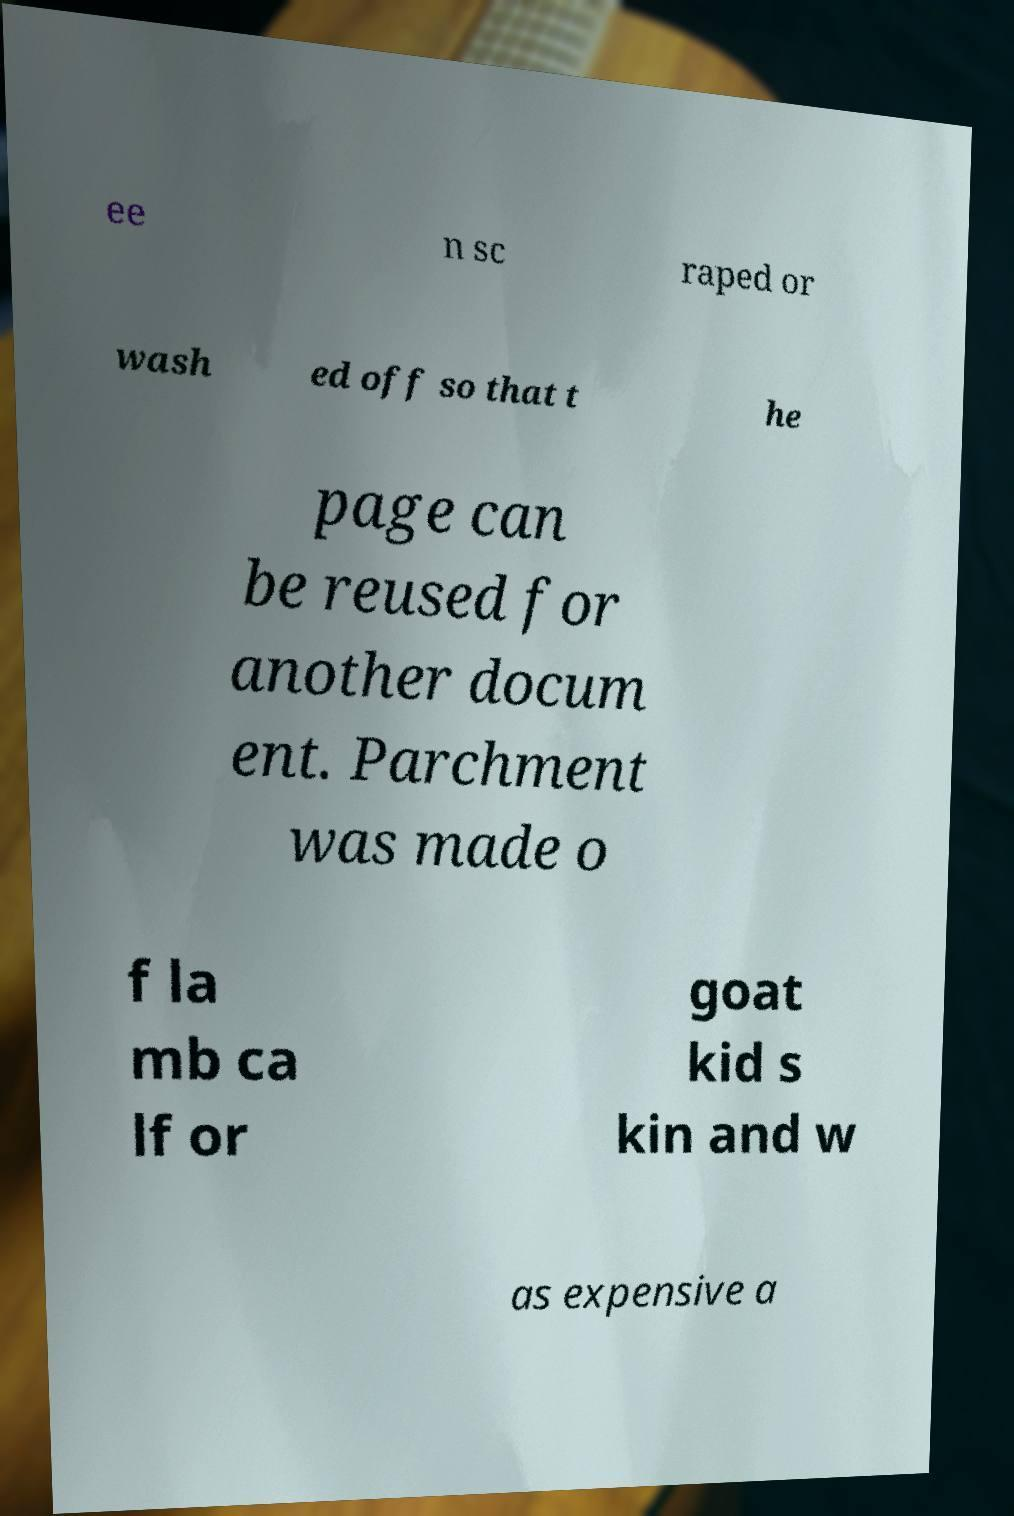For documentation purposes, I need the text within this image transcribed. Could you provide that? ee n sc raped or wash ed off so that t he page can be reused for another docum ent. Parchment was made o f la mb ca lf or goat kid s kin and w as expensive a 